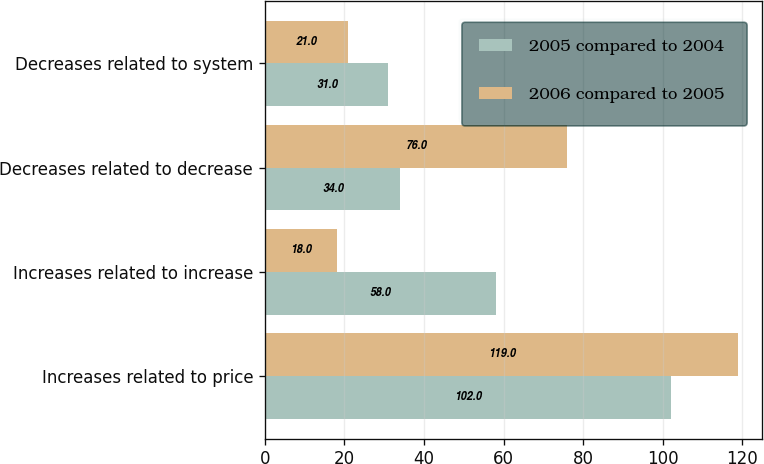<chart> <loc_0><loc_0><loc_500><loc_500><stacked_bar_chart><ecel><fcel>Increases related to price<fcel>Increases related to increase<fcel>Decreases related to decrease<fcel>Decreases related to system<nl><fcel>2005 compared to 2004<fcel>102<fcel>58<fcel>34<fcel>31<nl><fcel>2006 compared to 2005<fcel>119<fcel>18<fcel>76<fcel>21<nl></chart> 